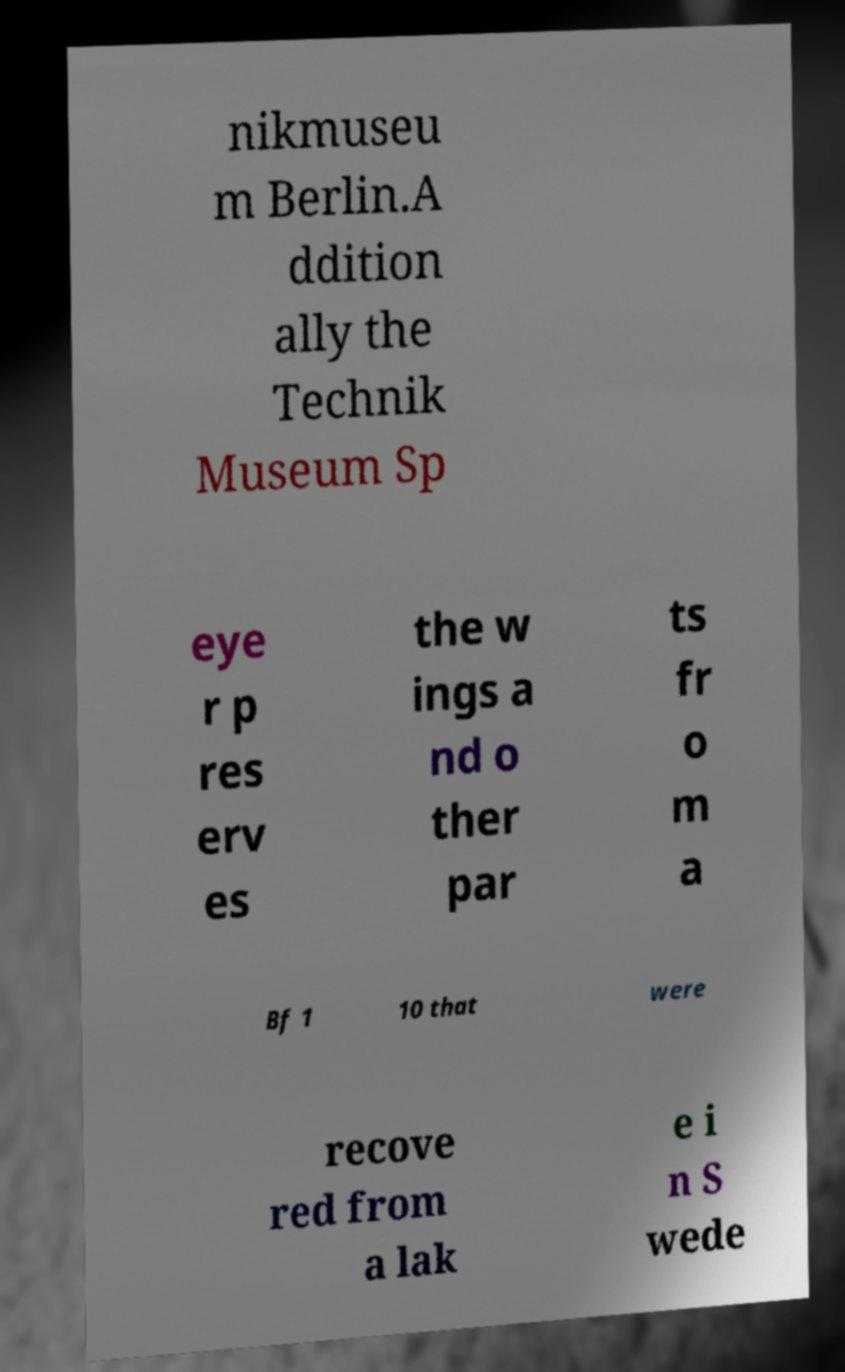Could you extract and type out the text from this image? nikmuseu m Berlin.A ddition ally the Technik Museum Sp eye r p res erv es the w ings a nd o ther par ts fr o m a Bf 1 10 that were recove red from a lak e i n S wede 